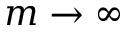<formula> <loc_0><loc_0><loc_500><loc_500>m \rightarrow \infty</formula> 